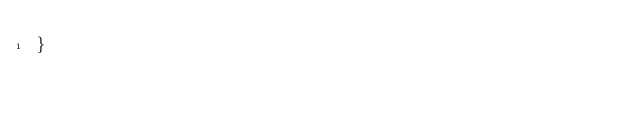Convert code to text. <code><loc_0><loc_0><loc_500><loc_500><_Rust_>}
</code> 